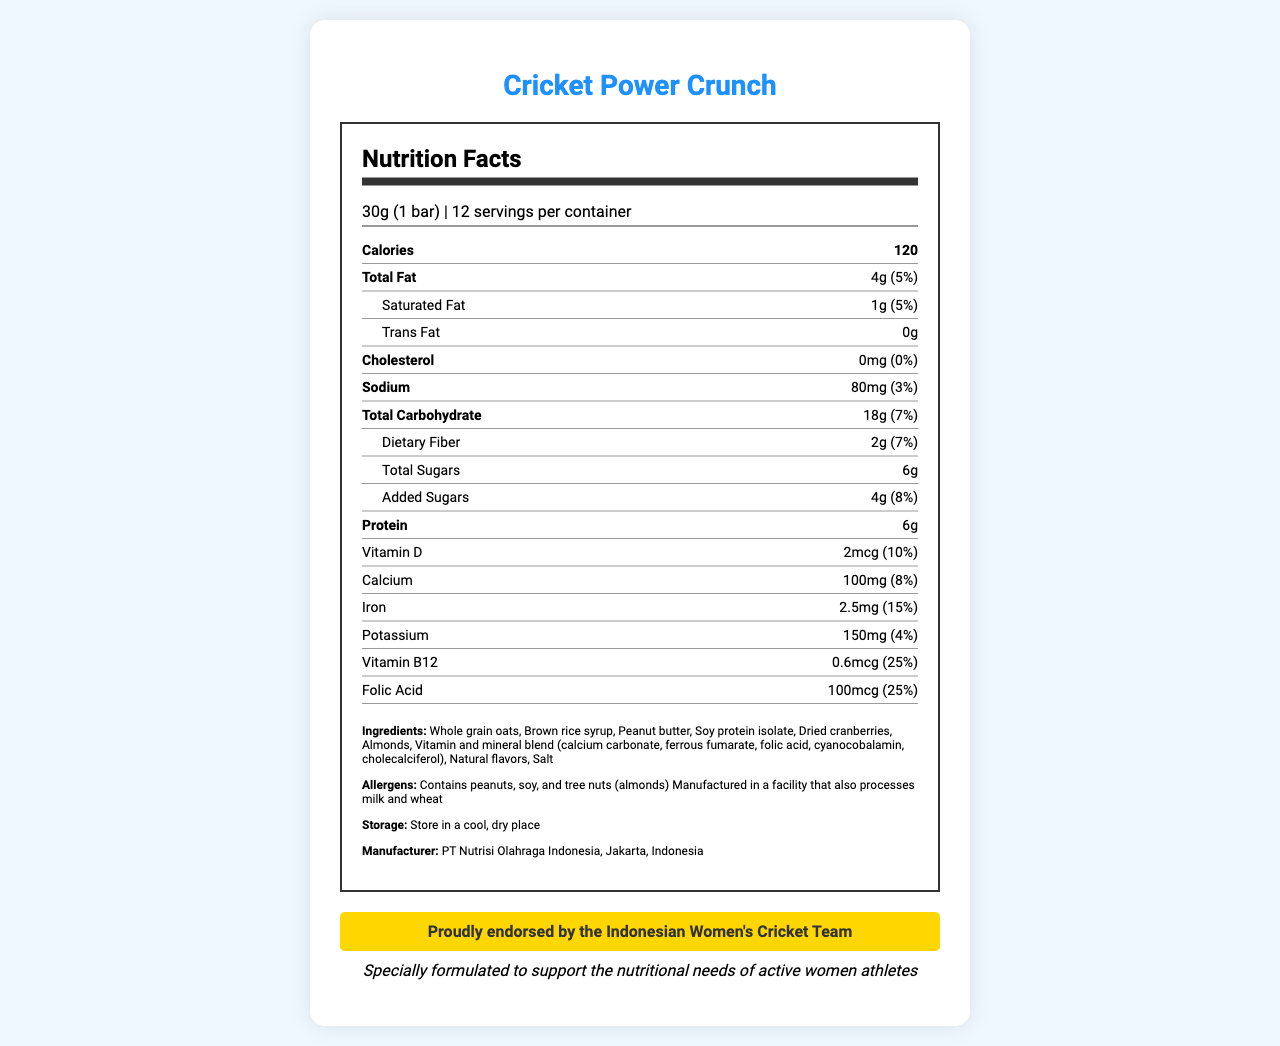what is the serving size of Cricket Power Crunch? The serving size is clearly listed as "30g (1 bar)" in the document.
Answer: 30g (1 bar) how many servings per container are there? The document states there are 12 servings per container.
Answer: 12 how many calories are in a single serving? The calories per serving are listed as 120.
Answer: 120 what are the main allergens in Cricket Power Crunch? The allergens listed include peanuts, soy, and tree nuts (almonds).
Answer: Peanuts, soy, and tree nuts (almonds) how much protein is in one serving of Cricket Power Crunch? The document shows that one serving contains 6g of protein.
Answer: 6g what is the daily value percentage of iron per serving? A. 8% B. 10% C. 15% D. 25% The daily value percentage of iron per serving is listed as 15%.
Answer: C which of the following vitamins is present at the highest percentage of daily value per serving? I. Vitamin D II. Calcium III. Iron IV. Vitamin B12 Vitamin B12 is present at 25% of the daily value, which is higher compared to the other vitamins listed.
Answer: IV does Cricket Power Crunch contain trans fat? The document states that the trans fat amount is 0g.
Answer: No summarize the main information about Cricket Power Crunch. The document provides detailed nutritional information, ingredients, allergens, and storage instructions for Cricket Power Crunch, emphasizing its endorsement by the Indonesian Women's Cricket Team and its nutritional benefits.
Answer: Cricket Power Crunch is a vitamin-fortified snack endorsed by the Indonesian Women's Cricket Team, designed to support the nutritional needs of active women athletes. Each 30g bar provides 120 calories, 4g of total fat, 6g of protein, and various vitamins and minerals. It contains allergens such as peanuts, soy, and almonds and should be stored in a cool, dry place. what is the total carbohydrate content per serving? The total carbohydrate content per serving is listed as 18g.
Answer: 18g how much calcium is in a single serving of Cricket Power Crunch? The document lists 100mg of calcium per serving.
Answer: 100mg does the product contain any artificial flavors? The document lists "Natural flavors" in the ingredients, indicating no artificial flavors.
Answer: No who manufactures Cricket Power Crunch? The document states that the manufacturer is PT Nutrisi Olahraga Indonesia, located in Jakarta, Indonesia.
Answer: PT Nutrisi Olahraga Indonesia, Jakarta, Indonesia how much sodium is there per serving? The sodium content per serving is listed as 80mg.
Answer: 80mg how much vitamin D does each serving contain? The amount of vitamin D per serving is 2mcg.
Answer: 2mcg is Cricket Power Crunch suitable for individuals allergic to milk? The product is manufactured in a facility that also processes milk, which means there could be cross-contamination.
Answer: No what natural sweetener is used in Cricket Power Crunch? One of the ingredients is brown rice syrup, which is a natural sweetener.
Answer: Brown rice syrup what can be inferred about the endorsement of Cricket Power Crunch? The document indicates that Cricket Power Crunch is proudly endorsed by the Indonesian Women's Cricket Team.
Answer: It is endorsed by the Indonesian Women's Cricket Team what is the daily value percentage of saturated fat per serving? The daily value percentage for saturated fat is listed as 5%.
Answer: 5% what is the intended use of Cricket Power Crunch as per the claim? The claim states that the product is specially formulated to support the nutritional needs of active women athletes.
Answer: To support the nutritional needs of active women athletes can you determine the price of Cricket Power Crunch from the document? The document does not provide any information about the price of Cricket Power Crunch.
Answer: Not enough information 